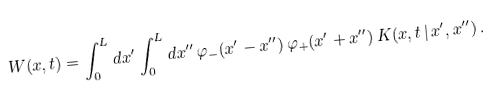Convert formula to latex. <formula><loc_0><loc_0><loc_500><loc_500>W ( x , t ) = \int _ { 0 } ^ { L } d x ^ { \prime } \int _ { 0 } ^ { L } d x ^ { \prime \prime } \, \varphi _ { - } ( x ^ { \prime } - x ^ { \prime \prime } ) \, \varphi _ { + } ( x ^ { \prime } + x ^ { \prime \prime } ) \, K ( x , t \, | \, x ^ { \prime } , x ^ { \prime \prime } ) \, .</formula> 